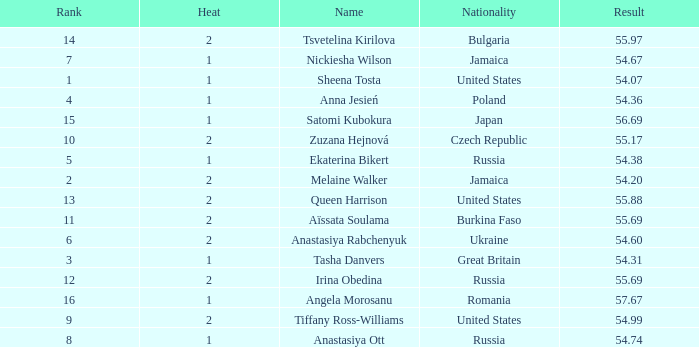Parse the full table. {'header': ['Rank', 'Heat', 'Name', 'Nationality', 'Result'], 'rows': [['14', '2', 'Tsvetelina Kirilova', 'Bulgaria', '55.97'], ['7', '1', 'Nickiesha Wilson', 'Jamaica', '54.67'], ['1', '1', 'Sheena Tosta', 'United States', '54.07'], ['4', '1', 'Anna Jesień', 'Poland', '54.36'], ['15', '1', 'Satomi Kubokura', 'Japan', '56.69'], ['10', '2', 'Zuzana Hejnová', 'Czech Republic', '55.17'], ['5', '1', 'Ekaterina Bikert', 'Russia', '54.38'], ['2', '2', 'Melaine Walker', 'Jamaica', '54.20'], ['13', '2', 'Queen Harrison', 'United States', '55.88'], ['11', '2', 'Aïssata Soulama', 'Burkina Faso', '55.69'], ['6', '2', 'Anastasiya Rabchenyuk', 'Ukraine', '54.60'], ['3', '1', 'Tasha Danvers', 'Great Britain', '54.31'], ['12', '2', 'Irina Obedina', 'Russia', '55.69'], ['16', '1', 'Angela Morosanu', 'Romania', '57.67'], ['9', '2', 'Tiffany Ross-Williams', 'United States', '54.99'], ['8', '1', 'Anastasiya Ott', 'Russia', '54.74']]} Who has a Result of 54.67? Nickiesha Wilson. 